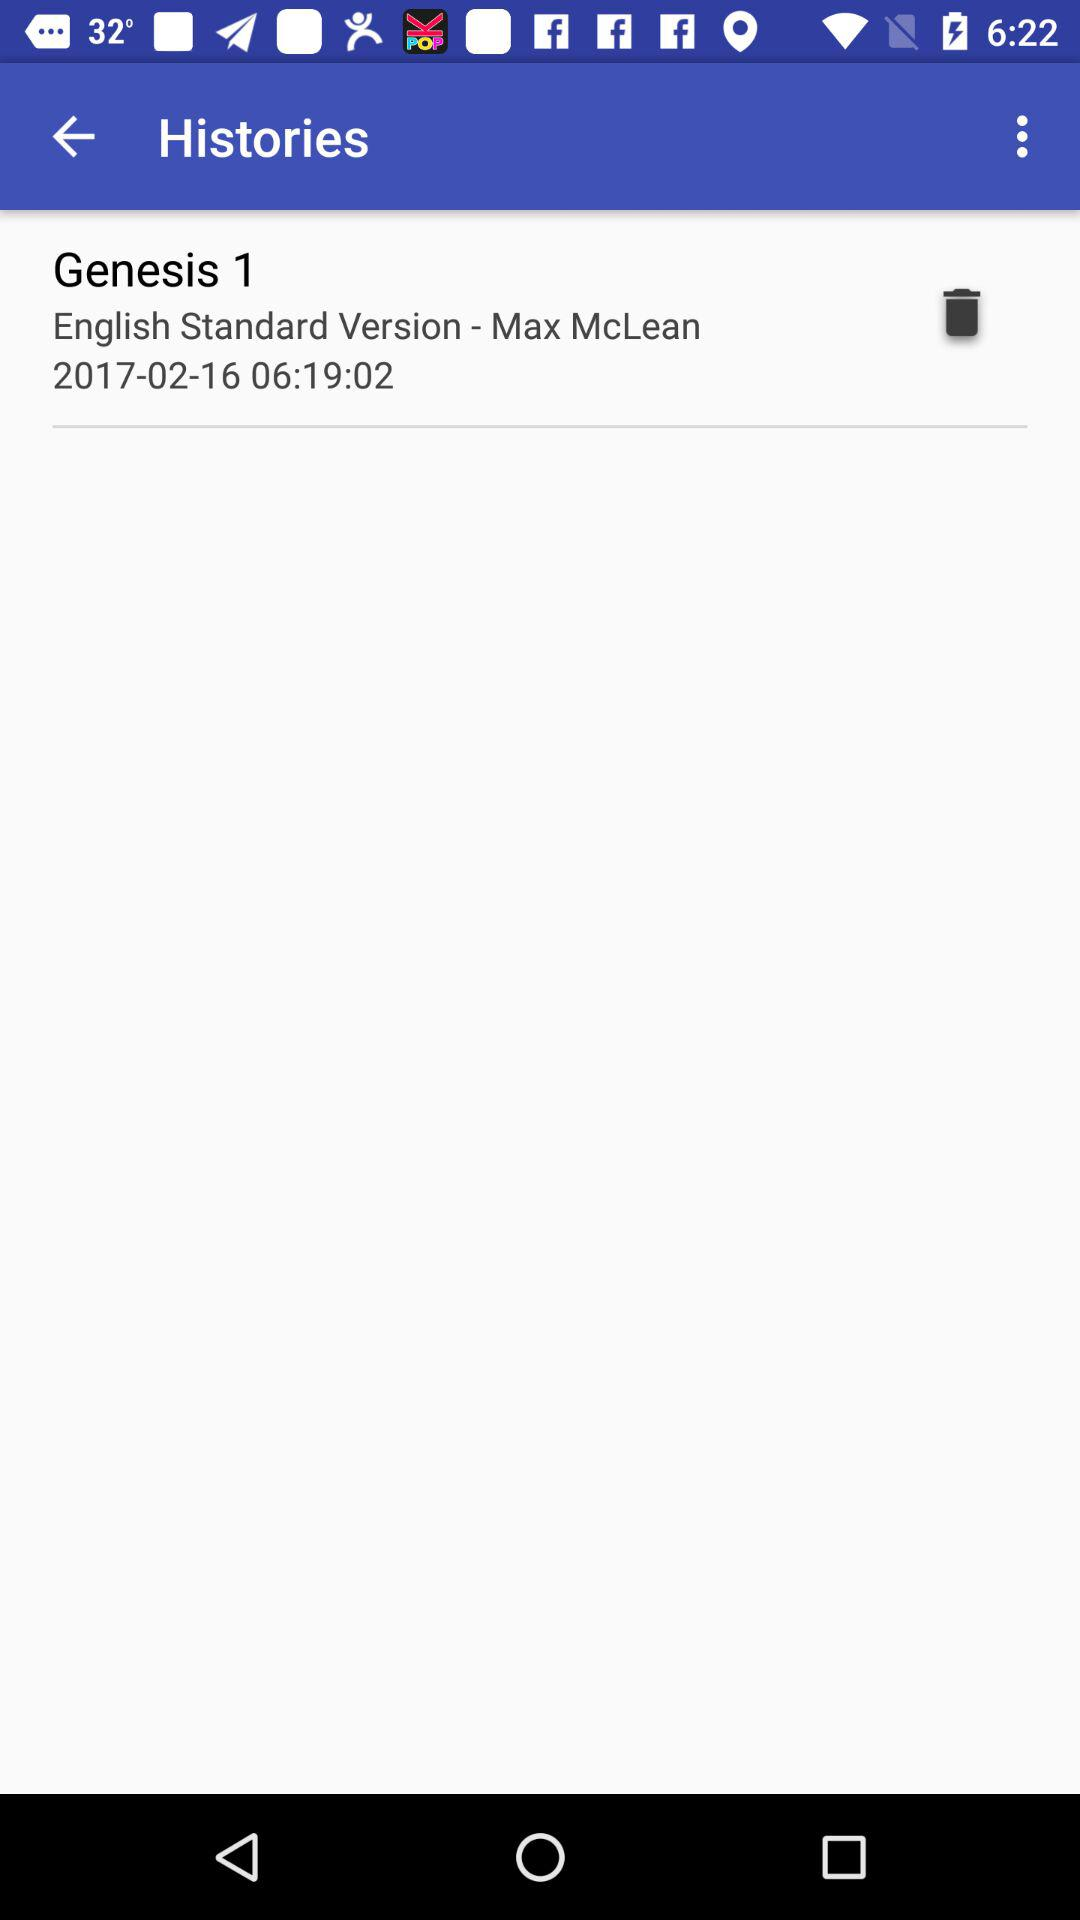What is the standard version?
When the provided information is insufficient, respond with <no answer>. <no answer> 